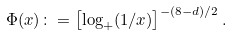<formula> <loc_0><loc_0><loc_500><loc_500>\Phi ( x ) \colon = \left [ \log _ { + } ( 1 / x ) \right ] ^ { - ( 8 - d ) / 2 } .</formula> 